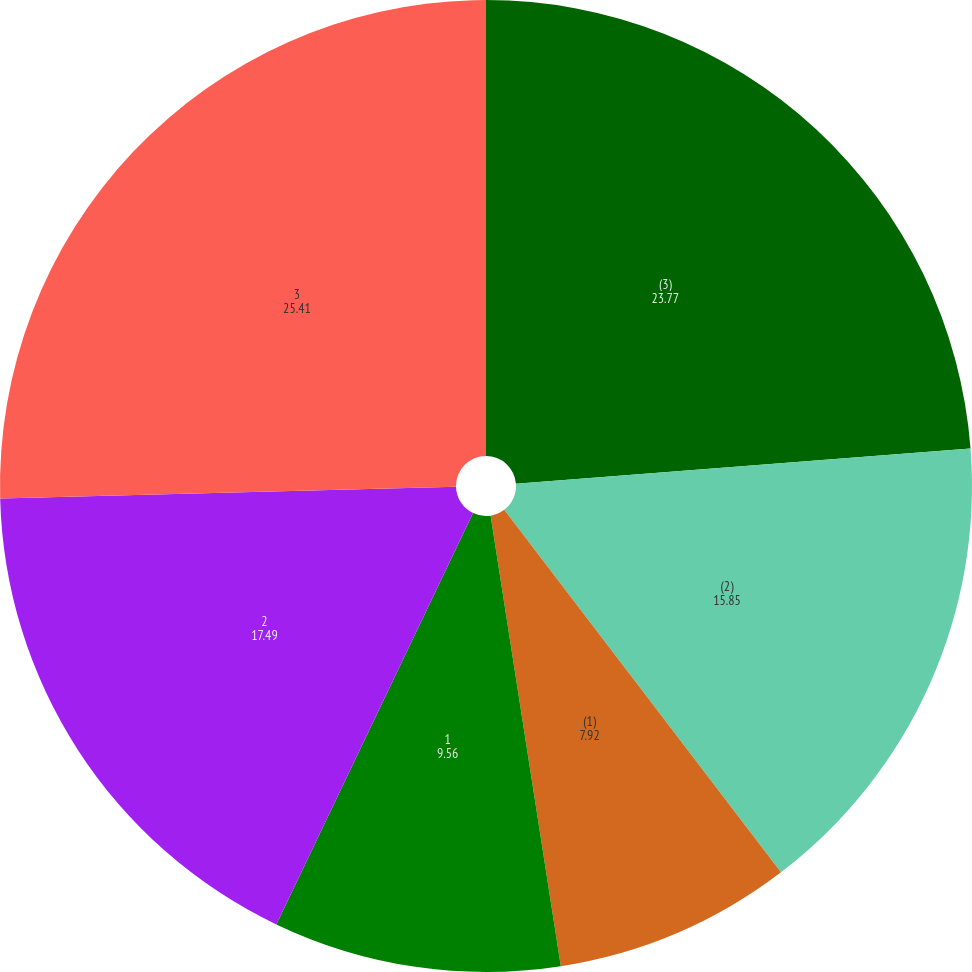Convert chart to OTSL. <chart><loc_0><loc_0><loc_500><loc_500><pie_chart><fcel>(3)<fcel>(2)<fcel>(1)<fcel>1<fcel>2<fcel>3<nl><fcel>23.77%<fcel>15.85%<fcel>7.92%<fcel>9.56%<fcel>17.49%<fcel>25.41%<nl></chart> 